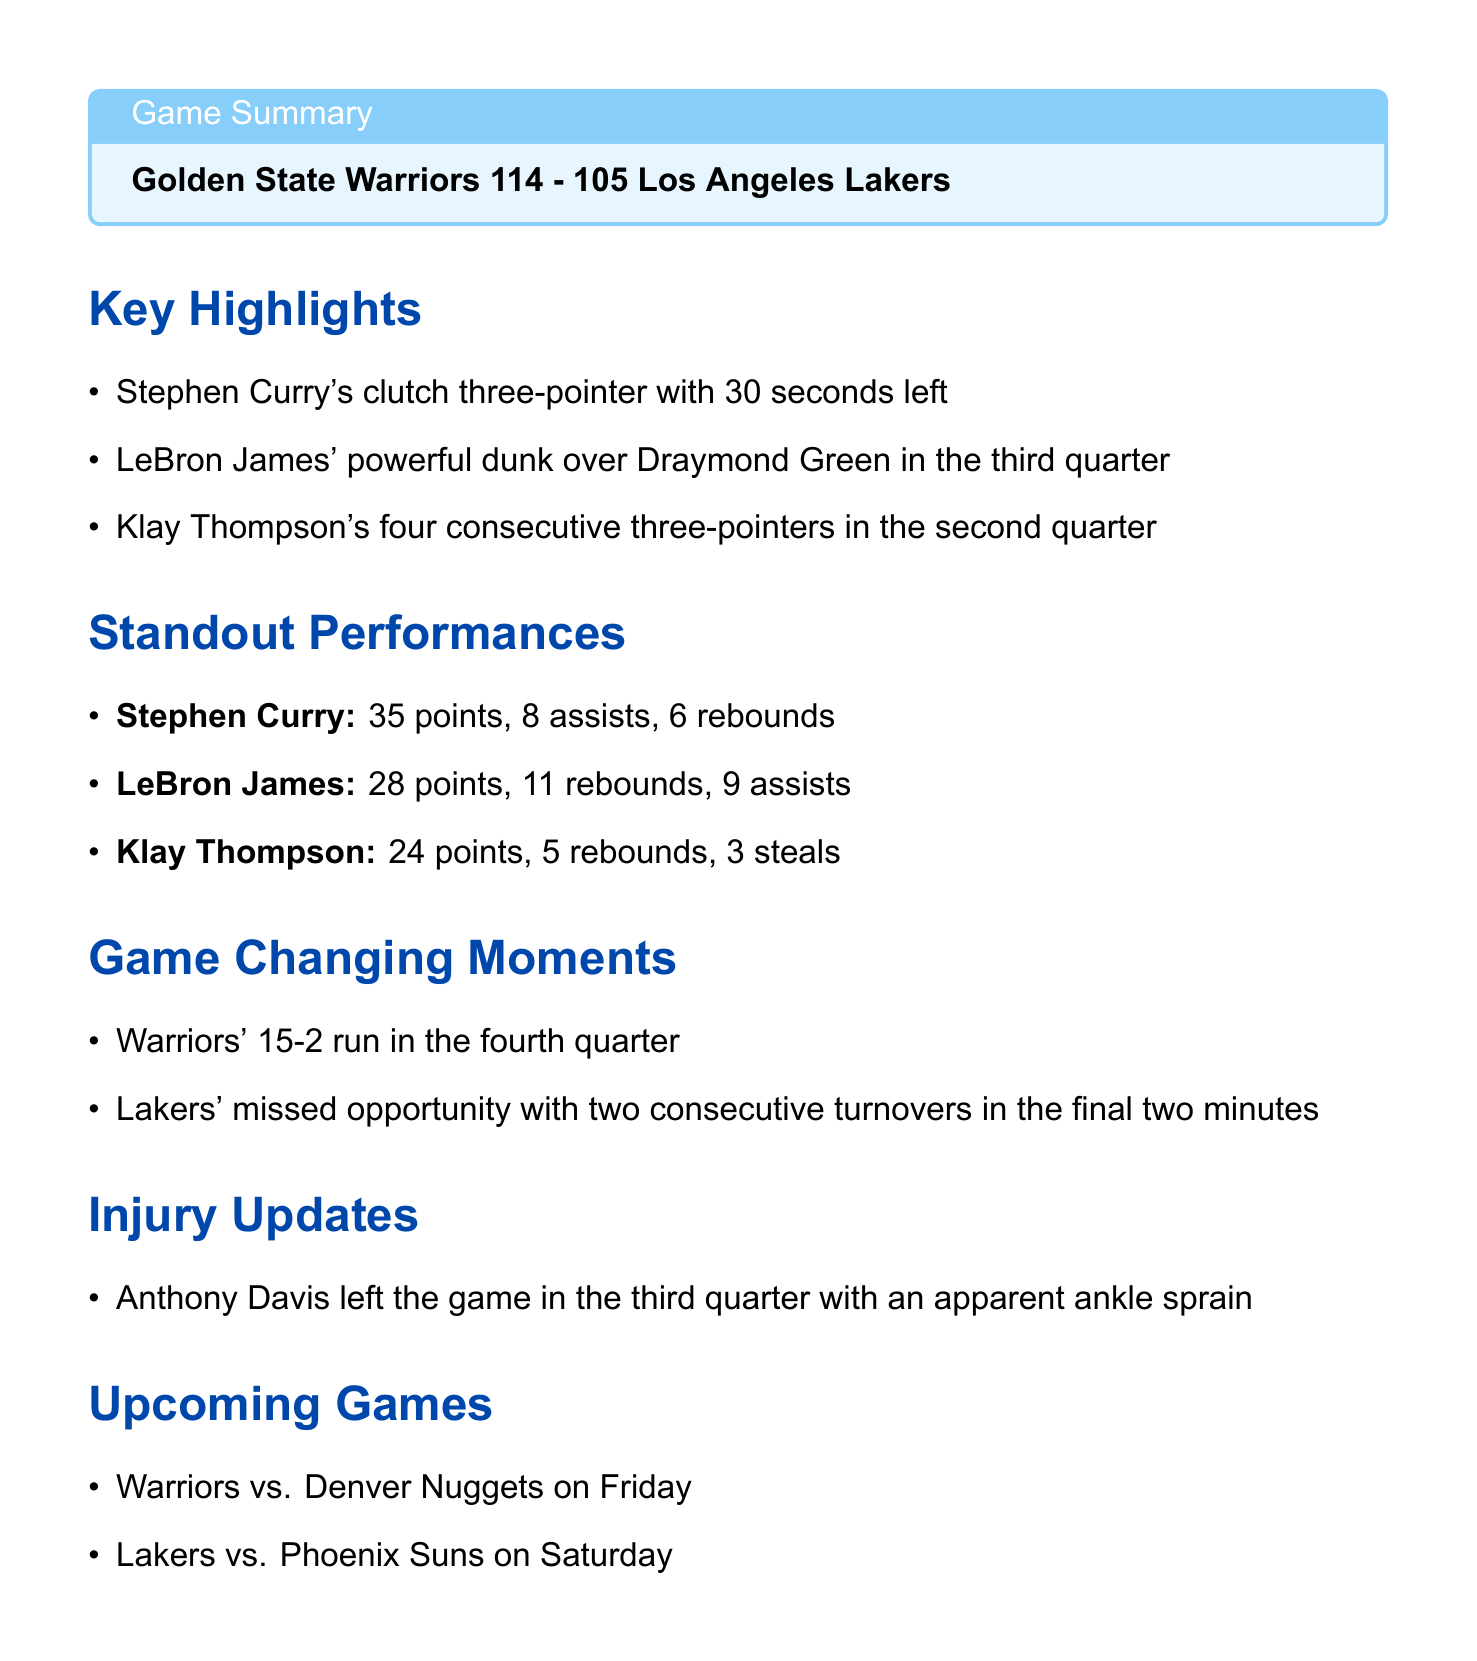What was the final score of the game? The final score is presented in the game summary section as "114-105".
Answer: 114-105 Who won the game? The winner of the game is mentioned in the game summary section.
Answer: Golden State Warriors What significant play did Stephen Curry make in the final moments? The document highlights Stephen Curry's clutch three-pointer specifically as a key moment.
Answer: clutch three-pointer How many points did LeBron James score? LeBron James' scoring performance is detailed in the standout performances section.
Answer: 28 points What injury did Anthony Davis suffer? The injury updates section directly states the nature of Anthony Davis' injury.
Answer: ankle sprain What was the Warriors' run in the fourth quarter? The standout moment noted in the game changing moments section provides this information.
Answer: 15-2 run When is the next game for the Warriors? The upcoming games section lists the Warriors' next opponent and date.
Answer: Friday Which player had the highest points in the game? The standout performances section summarizes player points and identifies the highest scorer.
Answer: Stephen Curry 